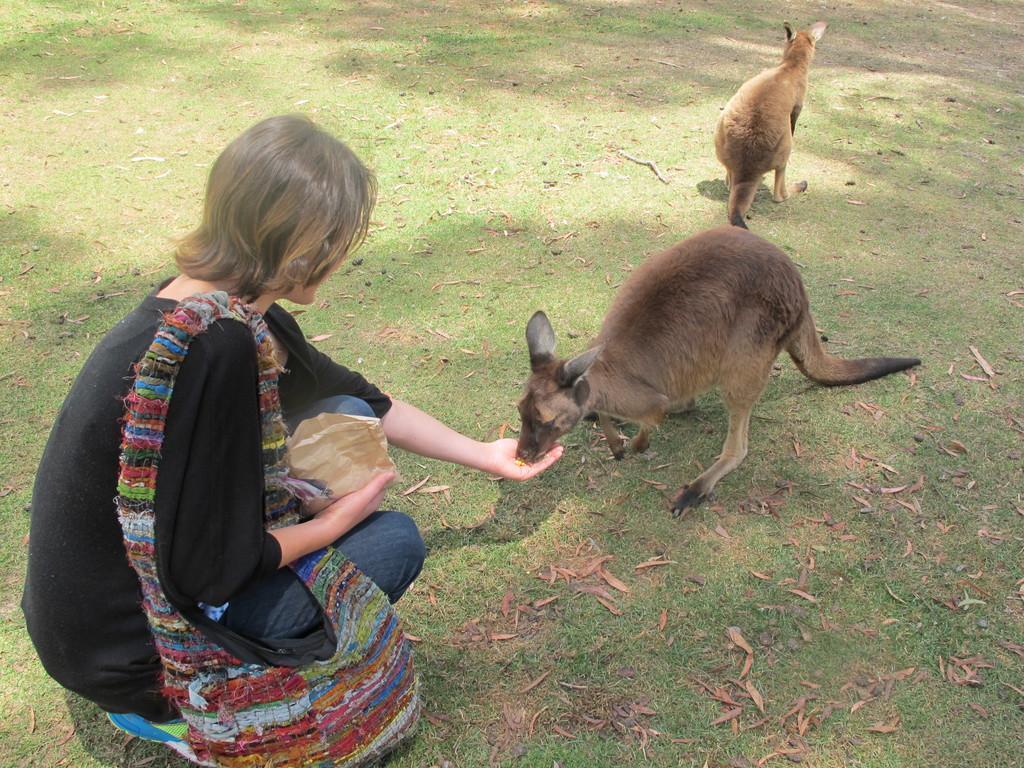Could you give a brief overview of what you see in this image? There is a lady wearing a bag and holding something in the hand. In front her there are kangaroos. On the ground there is grass. 